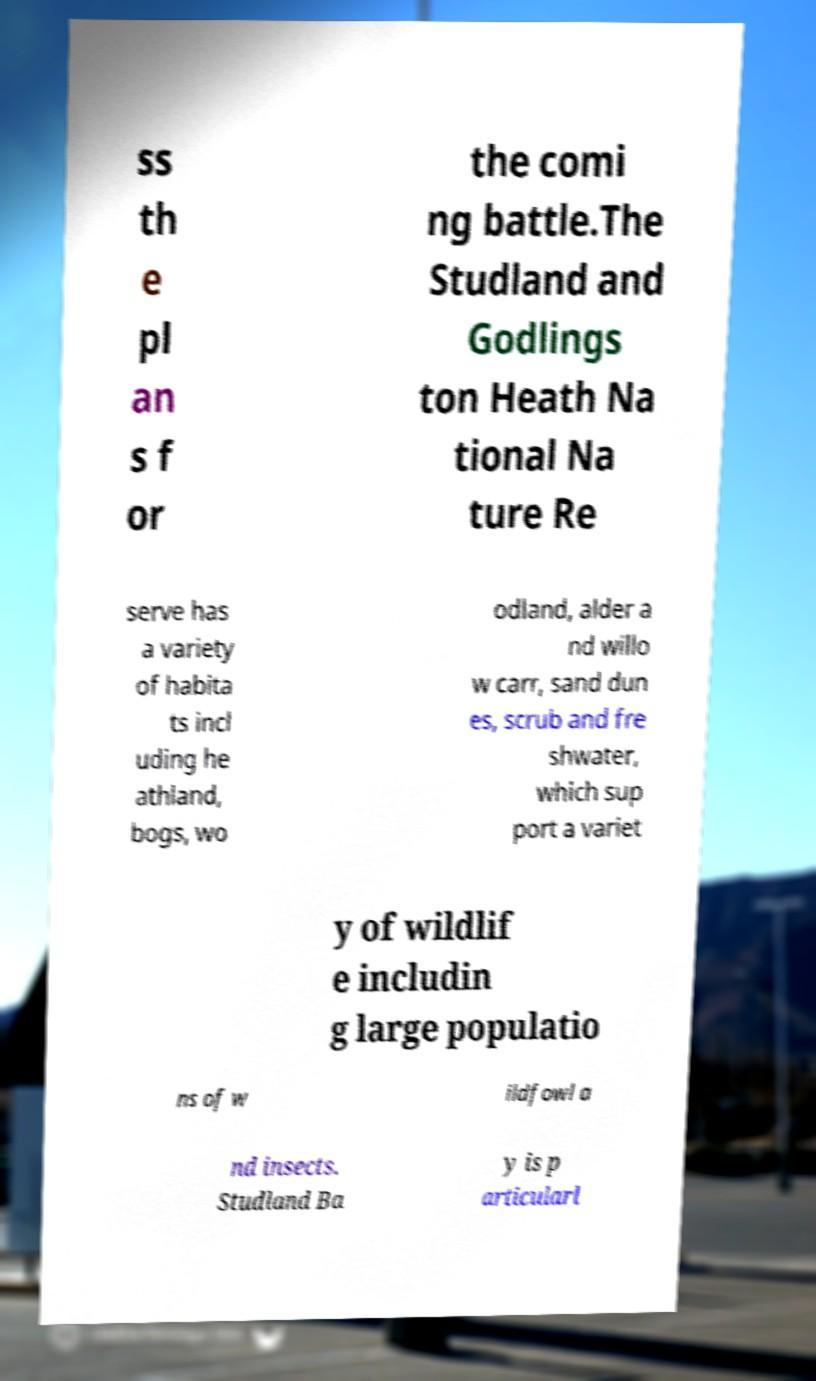Can you read and provide the text displayed in the image?This photo seems to have some interesting text. Can you extract and type it out for me? ss th e pl an s f or the comi ng battle.The Studland and Godlings ton Heath Na tional Na ture Re serve has a variety of habita ts incl uding he athland, bogs, wo odland, alder a nd willo w carr, sand dun es, scrub and fre shwater, which sup port a variet y of wildlif e includin g large populatio ns of w ildfowl a nd insects. Studland Ba y is p articularl 